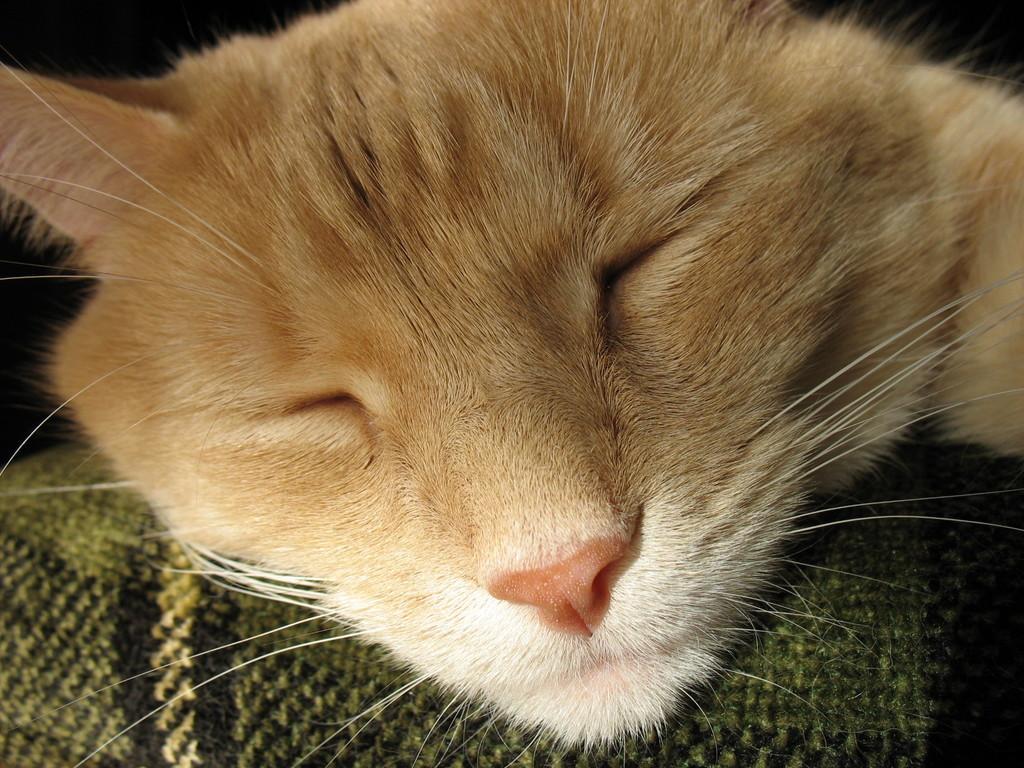In one or two sentences, can you explain what this image depicts? In the picture I can see a cat and some other thing. 